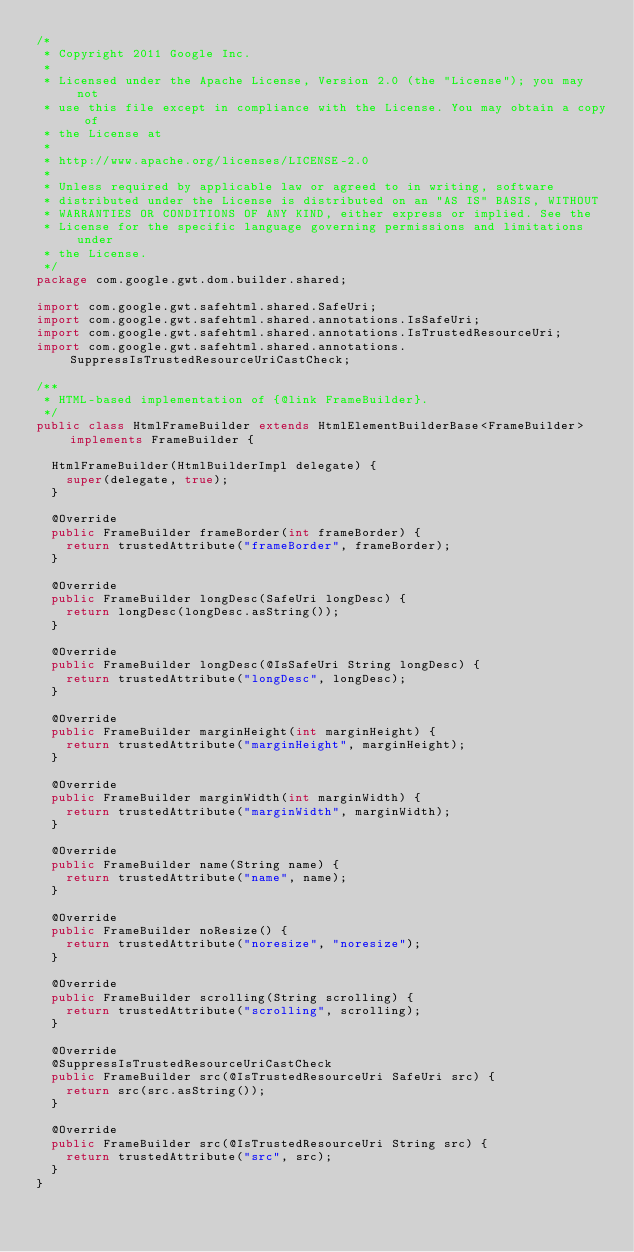Convert code to text. <code><loc_0><loc_0><loc_500><loc_500><_Java_>/*
 * Copyright 2011 Google Inc.
 * 
 * Licensed under the Apache License, Version 2.0 (the "License"); you may not
 * use this file except in compliance with the License. You may obtain a copy of
 * the License at
 * 
 * http://www.apache.org/licenses/LICENSE-2.0
 * 
 * Unless required by applicable law or agreed to in writing, software
 * distributed under the License is distributed on an "AS IS" BASIS, WITHOUT
 * WARRANTIES OR CONDITIONS OF ANY KIND, either express or implied. See the
 * License for the specific language governing permissions and limitations under
 * the License.
 */
package com.google.gwt.dom.builder.shared;

import com.google.gwt.safehtml.shared.SafeUri;
import com.google.gwt.safehtml.shared.annotations.IsSafeUri;
import com.google.gwt.safehtml.shared.annotations.IsTrustedResourceUri;
import com.google.gwt.safehtml.shared.annotations.SuppressIsTrustedResourceUriCastCheck;

/**
 * HTML-based implementation of {@link FrameBuilder}.
 */
public class HtmlFrameBuilder extends HtmlElementBuilderBase<FrameBuilder> implements FrameBuilder {

  HtmlFrameBuilder(HtmlBuilderImpl delegate) {
    super(delegate, true);
  }

  @Override
  public FrameBuilder frameBorder(int frameBorder) {
    return trustedAttribute("frameBorder", frameBorder);
  }

  @Override
  public FrameBuilder longDesc(SafeUri longDesc) {
    return longDesc(longDesc.asString());
  }

  @Override
  public FrameBuilder longDesc(@IsSafeUri String longDesc) {
    return trustedAttribute("longDesc", longDesc);
  }

  @Override
  public FrameBuilder marginHeight(int marginHeight) {
    return trustedAttribute("marginHeight", marginHeight);
  }

  @Override
  public FrameBuilder marginWidth(int marginWidth) {
    return trustedAttribute("marginWidth", marginWidth);
  }

  @Override
  public FrameBuilder name(String name) {
    return trustedAttribute("name", name);
  }

  @Override
  public FrameBuilder noResize() {
    return trustedAttribute("noresize", "noresize");
  }

  @Override
  public FrameBuilder scrolling(String scrolling) {
    return trustedAttribute("scrolling", scrolling);
  }

  @Override
  @SuppressIsTrustedResourceUriCastCheck
  public FrameBuilder src(@IsTrustedResourceUri SafeUri src) {
    return src(src.asString());
  }

  @Override
  public FrameBuilder src(@IsTrustedResourceUri String src) {
    return trustedAttribute("src", src);
  }
}
</code> 